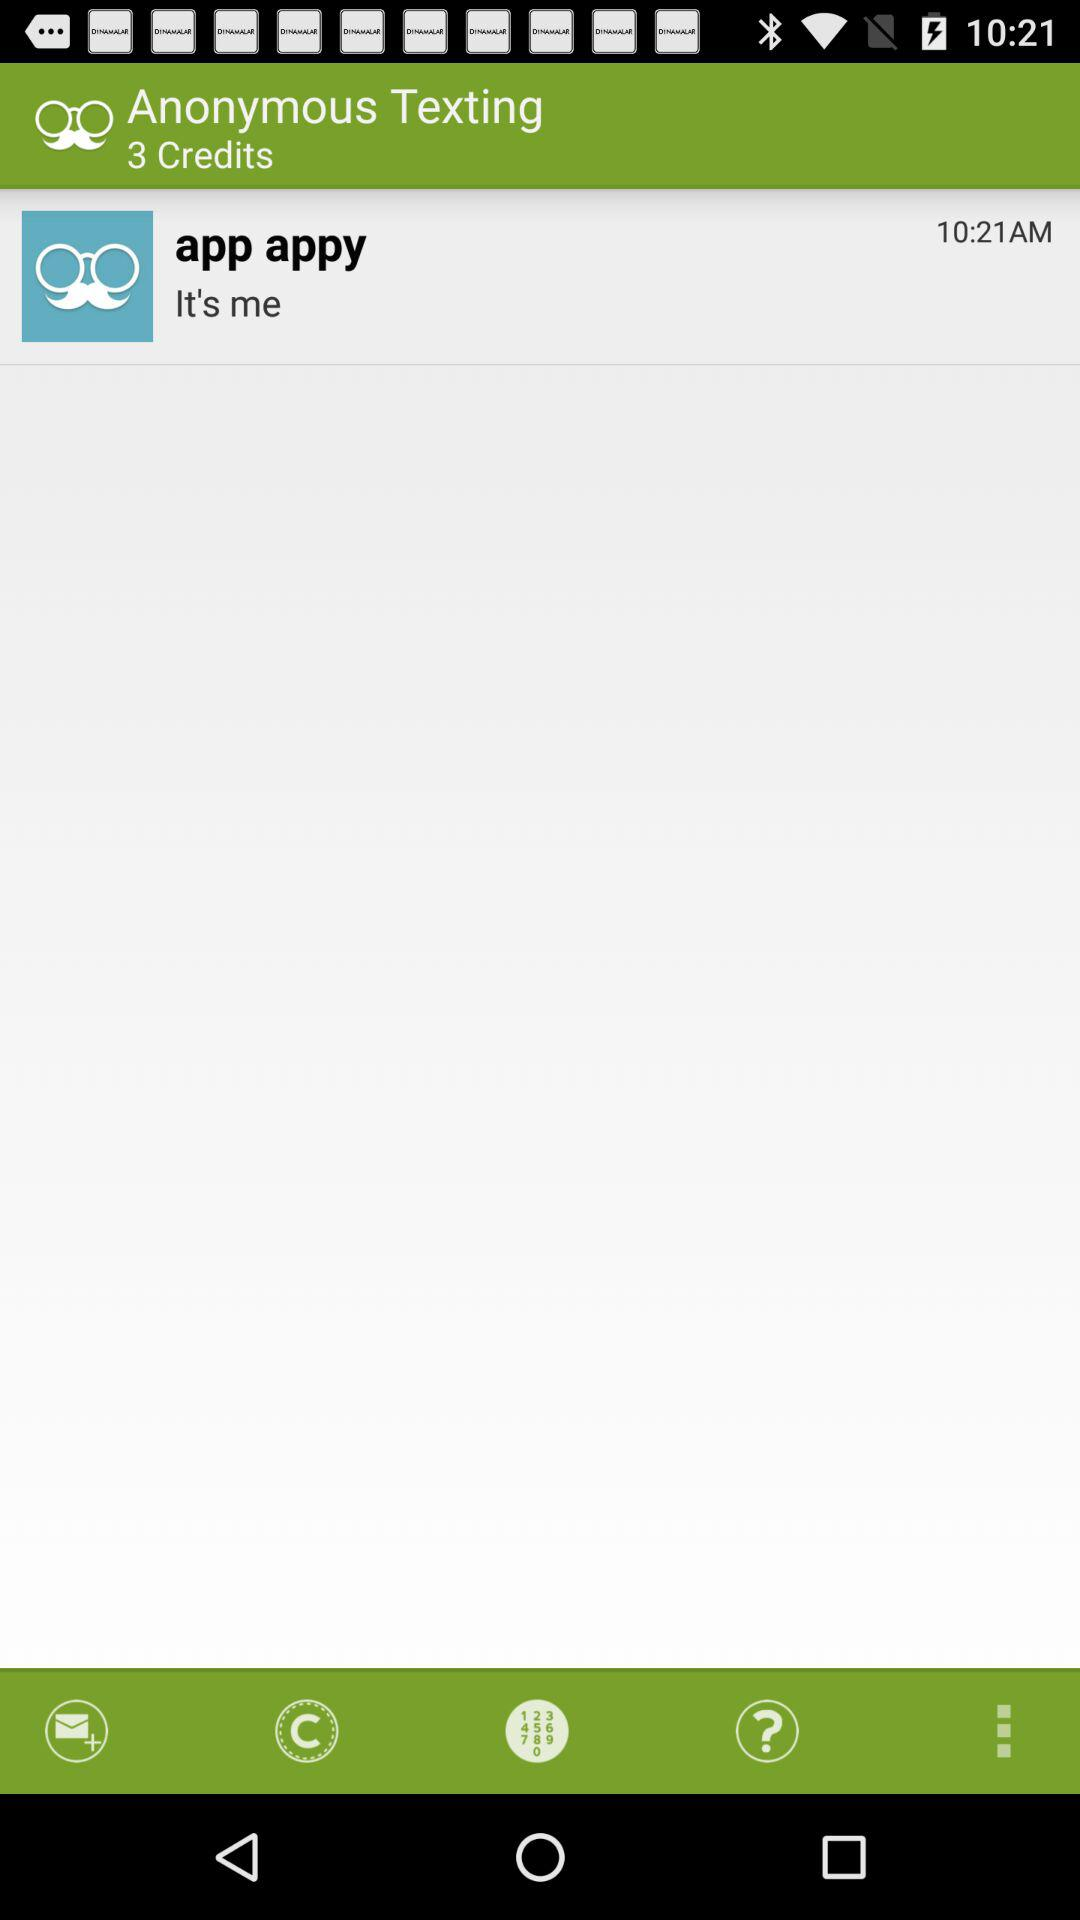What is the time given for "app appy"? The time given is 10:21 AM. 